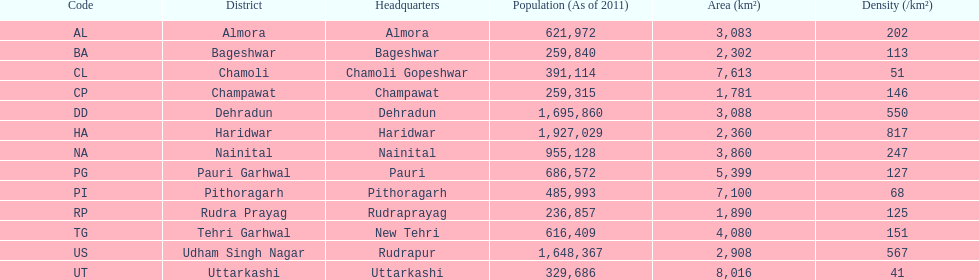What is the last code listed? UT. 